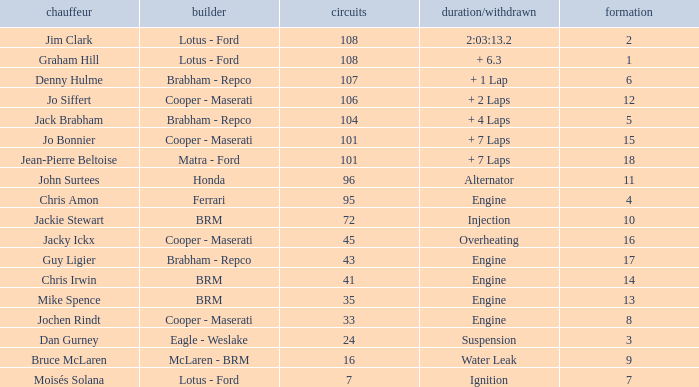What was the grid for suspension time/retired? 3.0. 